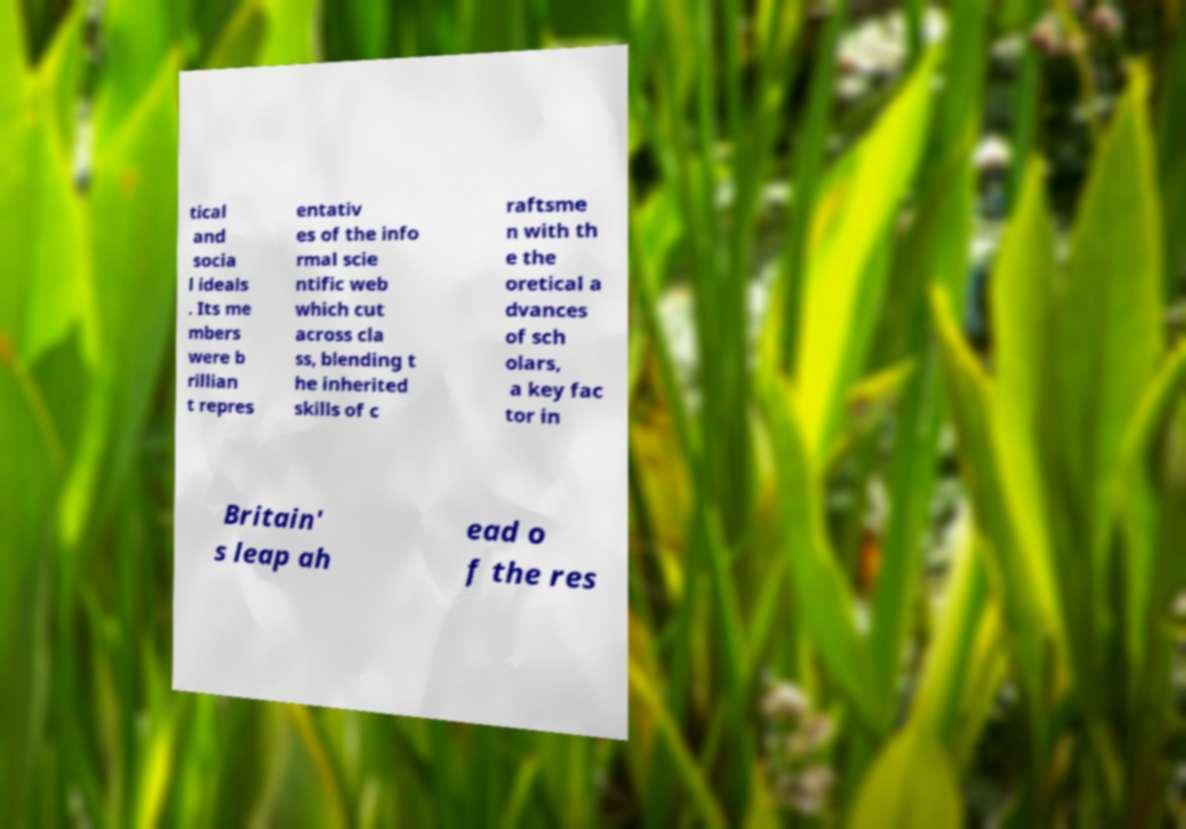For documentation purposes, I need the text within this image transcribed. Could you provide that? tical and socia l ideals . Its me mbers were b rillian t repres entativ es of the info rmal scie ntific web which cut across cla ss, blending t he inherited skills of c raftsme n with th e the oretical a dvances of sch olars, a key fac tor in Britain' s leap ah ead o f the res 